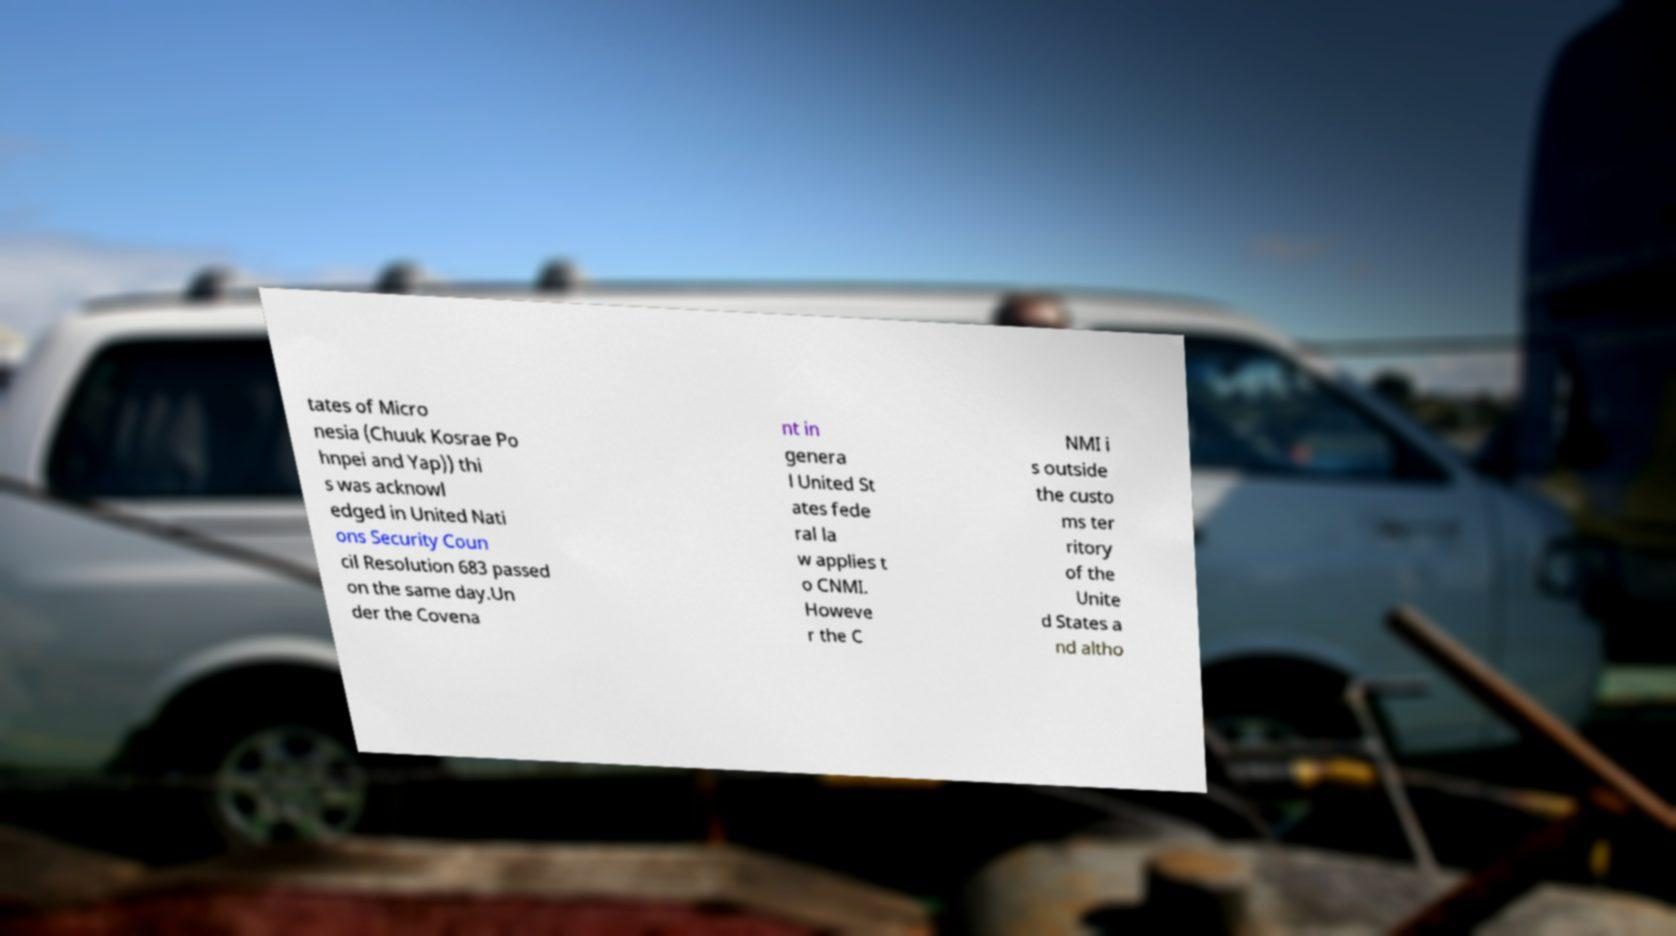Can you read and provide the text displayed in the image?This photo seems to have some interesting text. Can you extract and type it out for me? tates of Micro nesia (Chuuk Kosrae Po hnpei and Yap)) thi s was acknowl edged in United Nati ons Security Coun cil Resolution 683 passed on the same day.Un der the Covena nt in genera l United St ates fede ral la w applies t o CNMI. Howeve r the C NMI i s outside the custo ms ter ritory of the Unite d States a nd altho 